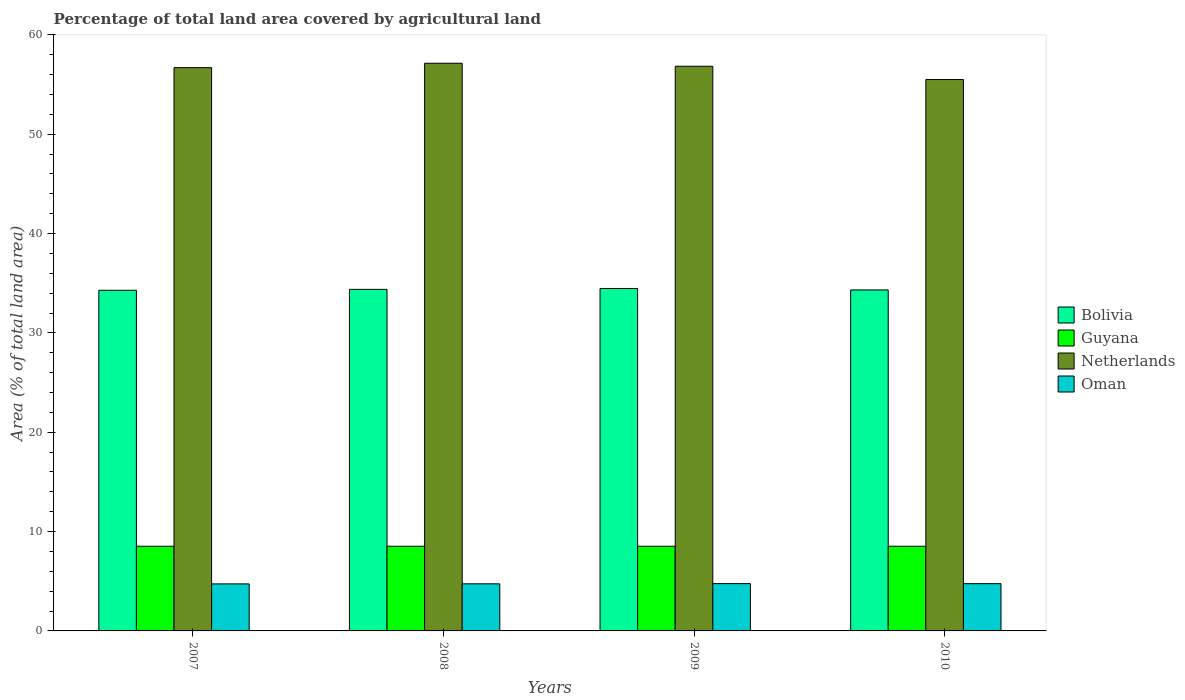How many different coloured bars are there?
Your response must be concise. 4. Are the number of bars on each tick of the X-axis equal?
Keep it short and to the point. Yes. What is the label of the 1st group of bars from the left?
Provide a short and direct response. 2007. What is the percentage of agricultural land in Oman in 2009?
Your response must be concise. 4.76. Across all years, what is the maximum percentage of agricultural land in Netherlands?
Offer a very short reply. 57.15. Across all years, what is the minimum percentage of agricultural land in Bolivia?
Make the answer very short. 34.29. What is the total percentage of agricultural land in Guyana in the graph?
Keep it short and to the point. 34.1. What is the difference between the percentage of agricultural land in Netherlands in 2007 and that in 2010?
Give a very brief answer. 1.2. What is the difference between the percentage of agricultural land in Bolivia in 2007 and the percentage of agricultural land in Netherlands in 2009?
Keep it short and to the point. -22.55. What is the average percentage of agricultural land in Bolivia per year?
Your answer should be compact. 34.37. In the year 2008, what is the difference between the percentage of agricultural land in Netherlands and percentage of agricultural land in Oman?
Make the answer very short. 52.41. What is the ratio of the percentage of agricultural land in Bolivia in 2007 to that in 2008?
Ensure brevity in your answer.  1. Is the percentage of agricultural land in Guyana in 2009 less than that in 2010?
Ensure brevity in your answer.  No. What is the difference between the highest and the second highest percentage of agricultural land in Oman?
Provide a succinct answer. 0. What is the difference between the highest and the lowest percentage of agricultural land in Netherlands?
Ensure brevity in your answer.  1.64. In how many years, is the percentage of agricultural land in Netherlands greater than the average percentage of agricultural land in Netherlands taken over all years?
Your answer should be compact. 3. Is it the case that in every year, the sum of the percentage of agricultural land in Oman and percentage of agricultural land in Netherlands is greater than the sum of percentage of agricultural land in Bolivia and percentage of agricultural land in Guyana?
Make the answer very short. Yes. What does the 1st bar from the left in 2010 represents?
Offer a very short reply. Bolivia. What does the 3rd bar from the right in 2009 represents?
Ensure brevity in your answer.  Guyana. How many bars are there?
Provide a short and direct response. 16. Are all the bars in the graph horizontal?
Keep it short and to the point. No. What is the difference between two consecutive major ticks on the Y-axis?
Offer a very short reply. 10. Does the graph contain grids?
Ensure brevity in your answer.  No. Where does the legend appear in the graph?
Offer a terse response. Center right. How are the legend labels stacked?
Ensure brevity in your answer.  Vertical. What is the title of the graph?
Offer a very short reply. Percentage of total land area covered by agricultural land. What is the label or title of the Y-axis?
Keep it short and to the point. Area (% of total land area). What is the Area (% of total land area) of Bolivia in 2007?
Offer a terse response. 34.29. What is the Area (% of total land area) in Guyana in 2007?
Your answer should be compact. 8.52. What is the Area (% of total land area) of Netherlands in 2007?
Provide a succinct answer. 56.71. What is the Area (% of total land area) in Oman in 2007?
Provide a short and direct response. 4.73. What is the Area (% of total land area) in Bolivia in 2008?
Make the answer very short. 34.38. What is the Area (% of total land area) of Guyana in 2008?
Keep it short and to the point. 8.52. What is the Area (% of total land area) in Netherlands in 2008?
Offer a very short reply. 57.15. What is the Area (% of total land area) of Oman in 2008?
Your answer should be compact. 4.74. What is the Area (% of total land area) in Bolivia in 2009?
Your answer should be compact. 34.47. What is the Area (% of total land area) of Guyana in 2009?
Provide a short and direct response. 8.52. What is the Area (% of total land area) of Netherlands in 2009?
Ensure brevity in your answer.  56.85. What is the Area (% of total land area) in Oman in 2009?
Keep it short and to the point. 4.76. What is the Area (% of total land area) of Bolivia in 2010?
Offer a terse response. 34.33. What is the Area (% of total land area) of Guyana in 2010?
Give a very brief answer. 8.52. What is the Area (% of total land area) in Netherlands in 2010?
Provide a short and direct response. 55.51. What is the Area (% of total land area) of Oman in 2010?
Keep it short and to the point. 4.76. Across all years, what is the maximum Area (% of total land area) in Bolivia?
Your answer should be very brief. 34.47. Across all years, what is the maximum Area (% of total land area) of Guyana?
Your answer should be very brief. 8.52. Across all years, what is the maximum Area (% of total land area) in Netherlands?
Provide a succinct answer. 57.15. Across all years, what is the maximum Area (% of total land area) of Oman?
Your answer should be compact. 4.76. Across all years, what is the minimum Area (% of total land area) in Bolivia?
Ensure brevity in your answer.  34.29. Across all years, what is the minimum Area (% of total land area) of Guyana?
Make the answer very short. 8.52. Across all years, what is the minimum Area (% of total land area) of Netherlands?
Keep it short and to the point. 55.51. Across all years, what is the minimum Area (% of total land area) in Oman?
Give a very brief answer. 4.73. What is the total Area (% of total land area) of Bolivia in the graph?
Your answer should be compact. 137.48. What is the total Area (% of total land area) of Guyana in the graph?
Your response must be concise. 34.1. What is the total Area (% of total land area) in Netherlands in the graph?
Make the answer very short. 226.21. What is the total Area (% of total land area) in Oman in the graph?
Give a very brief answer. 18.99. What is the difference between the Area (% of total land area) in Bolivia in 2007 and that in 2008?
Make the answer very short. -0.09. What is the difference between the Area (% of total land area) in Guyana in 2007 and that in 2008?
Keep it short and to the point. 0. What is the difference between the Area (% of total land area) in Netherlands in 2007 and that in 2008?
Provide a short and direct response. -0.44. What is the difference between the Area (% of total land area) in Oman in 2007 and that in 2008?
Offer a terse response. -0.01. What is the difference between the Area (% of total land area) of Bolivia in 2007 and that in 2009?
Your answer should be compact. -0.18. What is the difference between the Area (% of total land area) of Guyana in 2007 and that in 2009?
Your answer should be very brief. 0. What is the difference between the Area (% of total land area) in Netherlands in 2007 and that in 2009?
Keep it short and to the point. -0.14. What is the difference between the Area (% of total land area) in Oman in 2007 and that in 2009?
Offer a terse response. -0.03. What is the difference between the Area (% of total land area) of Bolivia in 2007 and that in 2010?
Make the answer very short. -0.04. What is the difference between the Area (% of total land area) in Netherlands in 2007 and that in 2010?
Your answer should be compact. 1.2. What is the difference between the Area (% of total land area) of Oman in 2007 and that in 2010?
Give a very brief answer. -0.02. What is the difference between the Area (% of total land area) in Bolivia in 2008 and that in 2009?
Provide a short and direct response. -0.08. What is the difference between the Area (% of total land area) in Netherlands in 2008 and that in 2009?
Provide a succinct answer. 0.3. What is the difference between the Area (% of total land area) of Oman in 2008 and that in 2009?
Offer a very short reply. -0.02. What is the difference between the Area (% of total land area) in Bolivia in 2008 and that in 2010?
Your answer should be compact. 0.06. What is the difference between the Area (% of total land area) of Netherlands in 2008 and that in 2010?
Keep it short and to the point. 1.64. What is the difference between the Area (% of total land area) of Oman in 2008 and that in 2010?
Keep it short and to the point. -0.02. What is the difference between the Area (% of total land area) of Bolivia in 2009 and that in 2010?
Your answer should be very brief. 0.14. What is the difference between the Area (% of total land area) in Netherlands in 2009 and that in 2010?
Give a very brief answer. 1.34. What is the difference between the Area (% of total land area) of Oman in 2009 and that in 2010?
Provide a short and direct response. 0. What is the difference between the Area (% of total land area) of Bolivia in 2007 and the Area (% of total land area) of Guyana in 2008?
Keep it short and to the point. 25.77. What is the difference between the Area (% of total land area) in Bolivia in 2007 and the Area (% of total land area) in Netherlands in 2008?
Keep it short and to the point. -22.85. What is the difference between the Area (% of total land area) in Bolivia in 2007 and the Area (% of total land area) in Oman in 2008?
Make the answer very short. 29.55. What is the difference between the Area (% of total land area) in Guyana in 2007 and the Area (% of total land area) in Netherlands in 2008?
Offer a very short reply. -48.62. What is the difference between the Area (% of total land area) of Guyana in 2007 and the Area (% of total land area) of Oman in 2008?
Offer a terse response. 3.78. What is the difference between the Area (% of total land area) in Netherlands in 2007 and the Area (% of total land area) in Oman in 2008?
Give a very brief answer. 51.97. What is the difference between the Area (% of total land area) in Bolivia in 2007 and the Area (% of total land area) in Guyana in 2009?
Provide a short and direct response. 25.77. What is the difference between the Area (% of total land area) of Bolivia in 2007 and the Area (% of total land area) of Netherlands in 2009?
Your response must be concise. -22.55. What is the difference between the Area (% of total land area) in Bolivia in 2007 and the Area (% of total land area) in Oman in 2009?
Your response must be concise. 29.53. What is the difference between the Area (% of total land area) of Guyana in 2007 and the Area (% of total land area) of Netherlands in 2009?
Offer a terse response. -48.32. What is the difference between the Area (% of total land area) of Guyana in 2007 and the Area (% of total land area) of Oman in 2009?
Offer a terse response. 3.76. What is the difference between the Area (% of total land area) of Netherlands in 2007 and the Area (% of total land area) of Oman in 2009?
Provide a succinct answer. 51.94. What is the difference between the Area (% of total land area) of Bolivia in 2007 and the Area (% of total land area) of Guyana in 2010?
Your answer should be compact. 25.77. What is the difference between the Area (% of total land area) of Bolivia in 2007 and the Area (% of total land area) of Netherlands in 2010?
Ensure brevity in your answer.  -21.22. What is the difference between the Area (% of total land area) in Bolivia in 2007 and the Area (% of total land area) in Oman in 2010?
Your response must be concise. 29.54. What is the difference between the Area (% of total land area) of Guyana in 2007 and the Area (% of total land area) of Netherlands in 2010?
Your answer should be compact. -46.98. What is the difference between the Area (% of total land area) of Guyana in 2007 and the Area (% of total land area) of Oman in 2010?
Provide a succinct answer. 3.77. What is the difference between the Area (% of total land area) of Netherlands in 2007 and the Area (% of total land area) of Oman in 2010?
Your answer should be very brief. 51.95. What is the difference between the Area (% of total land area) of Bolivia in 2008 and the Area (% of total land area) of Guyana in 2009?
Your answer should be very brief. 25.86. What is the difference between the Area (% of total land area) in Bolivia in 2008 and the Area (% of total land area) in Netherlands in 2009?
Provide a short and direct response. -22.46. What is the difference between the Area (% of total land area) of Bolivia in 2008 and the Area (% of total land area) of Oman in 2009?
Offer a very short reply. 29.62. What is the difference between the Area (% of total land area) in Guyana in 2008 and the Area (% of total land area) in Netherlands in 2009?
Give a very brief answer. -48.32. What is the difference between the Area (% of total land area) in Guyana in 2008 and the Area (% of total land area) in Oman in 2009?
Make the answer very short. 3.76. What is the difference between the Area (% of total land area) in Netherlands in 2008 and the Area (% of total land area) in Oman in 2009?
Your answer should be very brief. 52.38. What is the difference between the Area (% of total land area) of Bolivia in 2008 and the Area (% of total land area) of Guyana in 2010?
Keep it short and to the point. 25.86. What is the difference between the Area (% of total land area) of Bolivia in 2008 and the Area (% of total land area) of Netherlands in 2010?
Provide a short and direct response. -21.12. What is the difference between the Area (% of total land area) of Bolivia in 2008 and the Area (% of total land area) of Oman in 2010?
Provide a short and direct response. 29.63. What is the difference between the Area (% of total land area) in Guyana in 2008 and the Area (% of total land area) in Netherlands in 2010?
Your answer should be compact. -46.98. What is the difference between the Area (% of total land area) in Guyana in 2008 and the Area (% of total land area) in Oman in 2010?
Give a very brief answer. 3.77. What is the difference between the Area (% of total land area) in Netherlands in 2008 and the Area (% of total land area) in Oman in 2010?
Give a very brief answer. 52.39. What is the difference between the Area (% of total land area) in Bolivia in 2009 and the Area (% of total land area) in Guyana in 2010?
Your answer should be compact. 25.95. What is the difference between the Area (% of total land area) in Bolivia in 2009 and the Area (% of total land area) in Netherlands in 2010?
Your answer should be very brief. -21.04. What is the difference between the Area (% of total land area) in Bolivia in 2009 and the Area (% of total land area) in Oman in 2010?
Give a very brief answer. 29.71. What is the difference between the Area (% of total land area) of Guyana in 2009 and the Area (% of total land area) of Netherlands in 2010?
Your answer should be very brief. -46.98. What is the difference between the Area (% of total land area) of Guyana in 2009 and the Area (% of total land area) of Oman in 2010?
Keep it short and to the point. 3.77. What is the difference between the Area (% of total land area) in Netherlands in 2009 and the Area (% of total land area) in Oman in 2010?
Your answer should be compact. 52.09. What is the average Area (% of total land area) of Bolivia per year?
Provide a succinct answer. 34.37. What is the average Area (% of total land area) of Guyana per year?
Make the answer very short. 8.52. What is the average Area (% of total land area) of Netherlands per year?
Your response must be concise. 56.55. What is the average Area (% of total land area) of Oman per year?
Provide a succinct answer. 4.75. In the year 2007, what is the difference between the Area (% of total land area) of Bolivia and Area (% of total land area) of Guyana?
Your answer should be very brief. 25.77. In the year 2007, what is the difference between the Area (% of total land area) of Bolivia and Area (% of total land area) of Netherlands?
Offer a terse response. -22.41. In the year 2007, what is the difference between the Area (% of total land area) in Bolivia and Area (% of total land area) in Oman?
Offer a very short reply. 29.56. In the year 2007, what is the difference between the Area (% of total land area) of Guyana and Area (% of total land area) of Netherlands?
Make the answer very short. -48.18. In the year 2007, what is the difference between the Area (% of total land area) of Guyana and Area (% of total land area) of Oman?
Give a very brief answer. 3.79. In the year 2007, what is the difference between the Area (% of total land area) in Netherlands and Area (% of total land area) in Oman?
Keep it short and to the point. 51.97. In the year 2008, what is the difference between the Area (% of total land area) in Bolivia and Area (% of total land area) in Guyana?
Your answer should be compact. 25.86. In the year 2008, what is the difference between the Area (% of total land area) of Bolivia and Area (% of total land area) of Netherlands?
Offer a terse response. -22.76. In the year 2008, what is the difference between the Area (% of total land area) of Bolivia and Area (% of total land area) of Oman?
Your answer should be very brief. 29.64. In the year 2008, what is the difference between the Area (% of total land area) in Guyana and Area (% of total land area) in Netherlands?
Make the answer very short. -48.62. In the year 2008, what is the difference between the Area (% of total land area) of Guyana and Area (% of total land area) of Oman?
Provide a short and direct response. 3.78. In the year 2008, what is the difference between the Area (% of total land area) in Netherlands and Area (% of total land area) in Oman?
Provide a succinct answer. 52.41. In the year 2009, what is the difference between the Area (% of total land area) in Bolivia and Area (% of total land area) in Guyana?
Provide a short and direct response. 25.95. In the year 2009, what is the difference between the Area (% of total land area) in Bolivia and Area (% of total land area) in Netherlands?
Give a very brief answer. -22.38. In the year 2009, what is the difference between the Area (% of total land area) in Bolivia and Area (% of total land area) in Oman?
Your answer should be very brief. 29.71. In the year 2009, what is the difference between the Area (% of total land area) of Guyana and Area (% of total land area) of Netherlands?
Provide a succinct answer. -48.32. In the year 2009, what is the difference between the Area (% of total land area) of Guyana and Area (% of total land area) of Oman?
Ensure brevity in your answer.  3.76. In the year 2009, what is the difference between the Area (% of total land area) in Netherlands and Area (% of total land area) in Oman?
Your answer should be very brief. 52.08. In the year 2010, what is the difference between the Area (% of total land area) in Bolivia and Area (% of total land area) in Guyana?
Offer a terse response. 25.8. In the year 2010, what is the difference between the Area (% of total land area) of Bolivia and Area (% of total land area) of Netherlands?
Offer a very short reply. -21.18. In the year 2010, what is the difference between the Area (% of total land area) of Bolivia and Area (% of total land area) of Oman?
Make the answer very short. 29.57. In the year 2010, what is the difference between the Area (% of total land area) of Guyana and Area (% of total land area) of Netherlands?
Your response must be concise. -46.98. In the year 2010, what is the difference between the Area (% of total land area) in Guyana and Area (% of total land area) in Oman?
Ensure brevity in your answer.  3.77. In the year 2010, what is the difference between the Area (% of total land area) of Netherlands and Area (% of total land area) of Oman?
Provide a short and direct response. 50.75. What is the ratio of the Area (% of total land area) in Bolivia in 2007 to that in 2008?
Make the answer very short. 1. What is the ratio of the Area (% of total land area) of Guyana in 2007 to that in 2008?
Provide a short and direct response. 1. What is the ratio of the Area (% of total land area) in Oman in 2007 to that in 2008?
Your answer should be very brief. 1. What is the ratio of the Area (% of total land area) of Netherlands in 2007 to that in 2009?
Offer a very short reply. 1. What is the ratio of the Area (% of total land area) in Netherlands in 2007 to that in 2010?
Give a very brief answer. 1.02. What is the ratio of the Area (% of total land area) of Bolivia in 2008 to that in 2009?
Offer a terse response. 1. What is the ratio of the Area (% of total land area) in Guyana in 2008 to that in 2009?
Offer a very short reply. 1. What is the ratio of the Area (% of total land area) of Oman in 2008 to that in 2009?
Provide a succinct answer. 1. What is the ratio of the Area (% of total land area) of Bolivia in 2008 to that in 2010?
Your response must be concise. 1. What is the ratio of the Area (% of total land area) in Netherlands in 2008 to that in 2010?
Your answer should be compact. 1.03. What is the ratio of the Area (% of total land area) in Oman in 2008 to that in 2010?
Offer a terse response. 1. What is the ratio of the Area (% of total land area) in Bolivia in 2009 to that in 2010?
Give a very brief answer. 1. What is the ratio of the Area (% of total land area) in Netherlands in 2009 to that in 2010?
Ensure brevity in your answer.  1.02. What is the ratio of the Area (% of total land area) of Oman in 2009 to that in 2010?
Your answer should be compact. 1. What is the difference between the highest and the second highest Area (% of total land area) of Bolivia?
Provide a succinct answer. 0.08. What is the difference between the highest and the second highest Area (% of total land area) in Netherlands?
Keep it short and to the point. 0.3. What is the difference between the highest and the second highest Area (% of total land area) of Oman?
Make the answer very short. 0. What is the difference between the highest and the lowest Area (% of total land area) of Bolivia?
Provide a succinct answer. 0.18. What is the difference between the highest and the lowest Area (% of total land area) in Guyana?
Provide a succinct answer. 0. What is the difference between the highest and the lowest Area (% of total land area) of Netherlands?
Ensure brevity in your answer.  1.64. What is the difference between the highest and the lowest Area (% of total land area) in Oman?
Give a very brief answer. 0.03. 